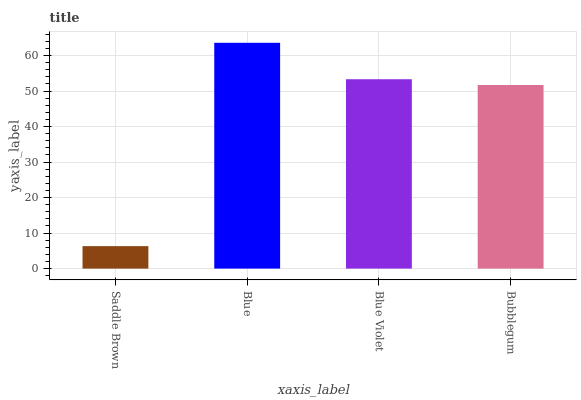Is Saddle Brown the minimum?
Answer yes or no. Yes. Is Blue the maximum?
Answer yes or no. Yes. Is Blue Violet the minimum?
Answer yes or no. No. Is Blue Violet the maximum?
Answer yes or no. No. Is Blue greater than Blue Violet?
Answer yes or no. Yes. Is Blue Violet less than Blue?
Answer yes or no. Yes. Is Blue Violet greater than Blue?
Answer yes or no. No. Is Blue less than Blue Violet?
Answer yes or no. No. Is Blue Violet the high median?
Answer yes or no. Yes. Is Bubblegum the low median?
Answer yes or no. Yes. Is Saddle Brown the high median?
Answer yes or no. No. Is Saddle Brown the low median?
Answer yes or no. No. 